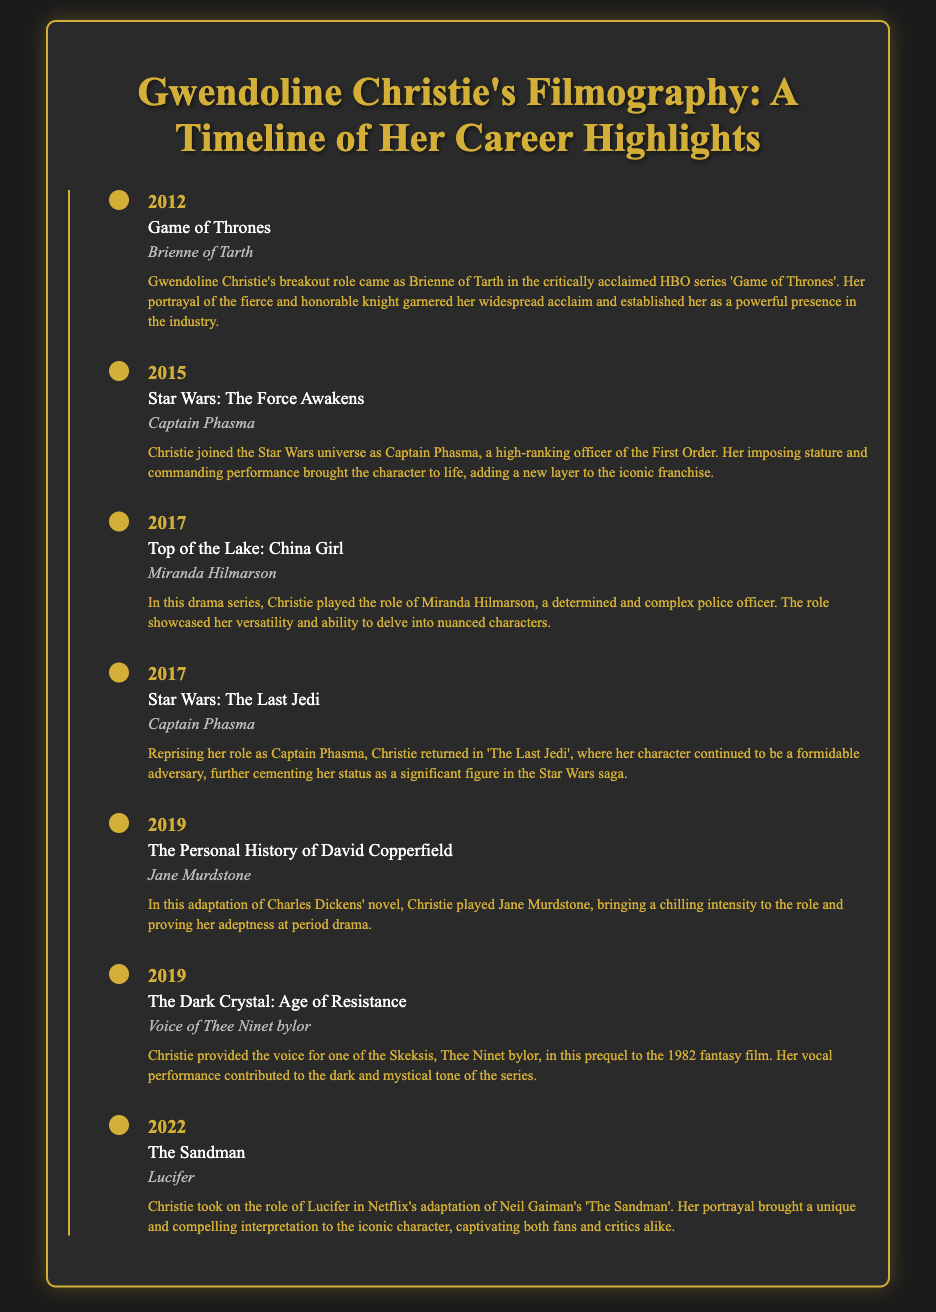What was Gwendoline Christie's breakout role? Gwendoline Christie's breakout role was Brienne of Tarth in 'Game of Thrones'.
Answer: Brienne of Tarth In which year did Gwendoline Christie play Captain Phasma for the first time? Gwendoline Christie first played Captain Phasma in the year 2015 in 'Star Wars: The Force Awakens'.
Answer: 2015 What character did Gwendoline Christie portray in 'The Sandman'? In 'The Sandman', Gwendoline Christie portrayed the character Lucifer.
Answer: Lucifer How many times did Gwendoline Christie appear as Captain Phasma? She appeared as Captain Phasma twice, in 'The Force Awakens' and 'The Last Jedi'.
Answer: Twice What role did Christie play in the adaptation of Charles Dickens' novel? Gwendoline Christie played the role of Jane Murdstone in 'The Personal History of David Copperfield'.
Answer: Jane Murdstone Which character did Christie voice in 'The Dark Crystal: Age of Resistance'? In 'The Dark Crystal: Age of Resistance', Christie voiced Thee Ninet bylor.
Answer: Thee Ninet bylor What genre of character did Christie portray in 'Top of the Lake: China Girl'? In 'Top of the Lake: China Girl', Christie portrayed a police officer.
Answer: Police officer What was a significant aspect of Christie's portrayal of Brienne of Tarth? Christie's portrayal of Brienne of Tarth was notable for her fierce and honorable nature.
Answer: Fierce and honorable nature 